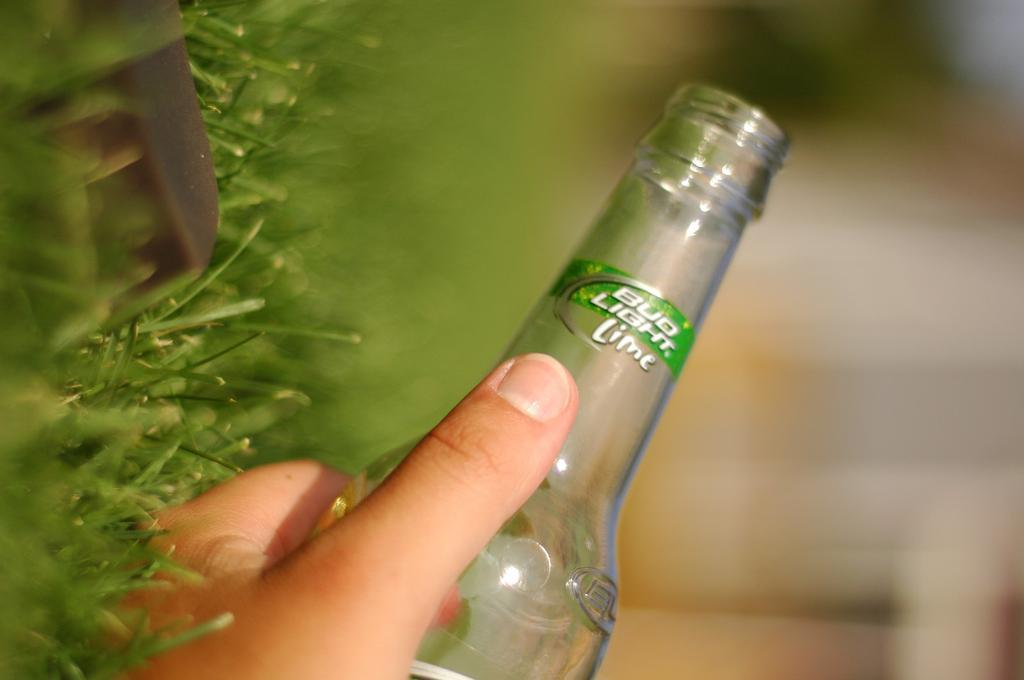What is the main subject of the image? There is a person in the image. What is the person holding in the image? The person is holding a bottle. What type of natural environment can be seen in the image? Grass is visible in the bottom left side of the image, which indicates that the image is set in a natural environment, likely outdoors. We start by identifying the main subject of the image, which is the person. Then, we describe what the person is holding, which is a bottle. Finally, we mention the natural environment by pointing out the presence of grass. Absurd Question/Answer: What type of quiver can be seen on the person's back in the image? There is no quiver present on the person's back in the image. What type of rule is the person using to measure the distance between the trees in the image? There is no rule present in the image, and the person is not measuring any distances. 